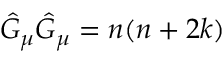Convert formula to latex. <formula><loc_0><loc_0><loc_500><loc_500>\hat { G } _ { \mu } \hat { G } _ { \mu } = n ( n + 2 k )</formula> 